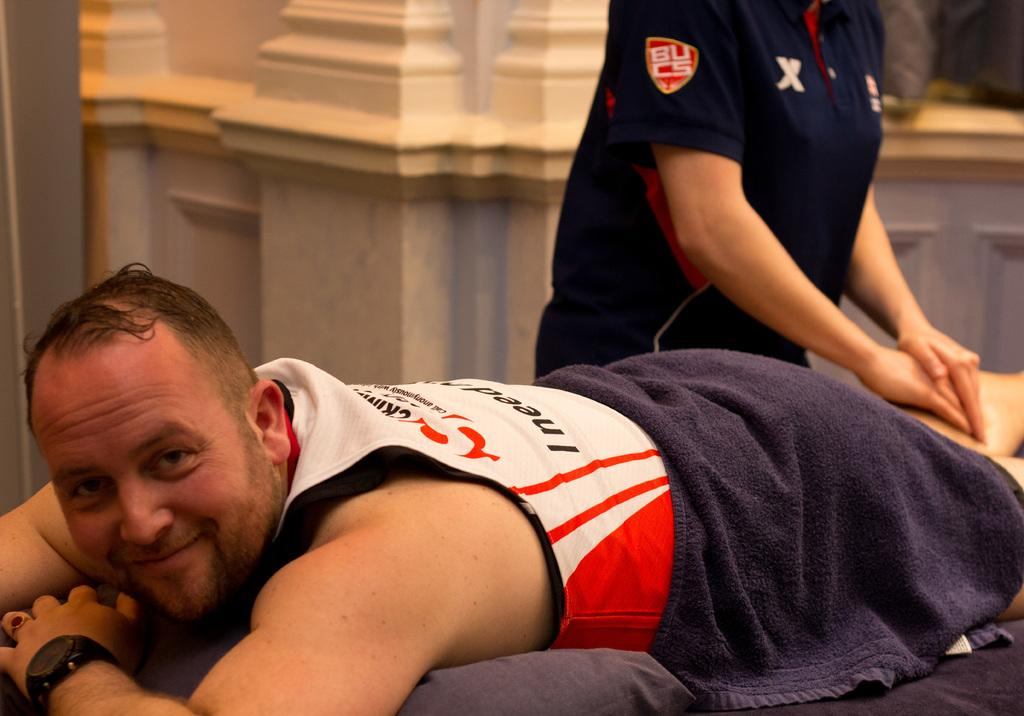<image>
Provide a brief description of the given image. A person with the letters BUCS on their sleeve massages someone's leg. 